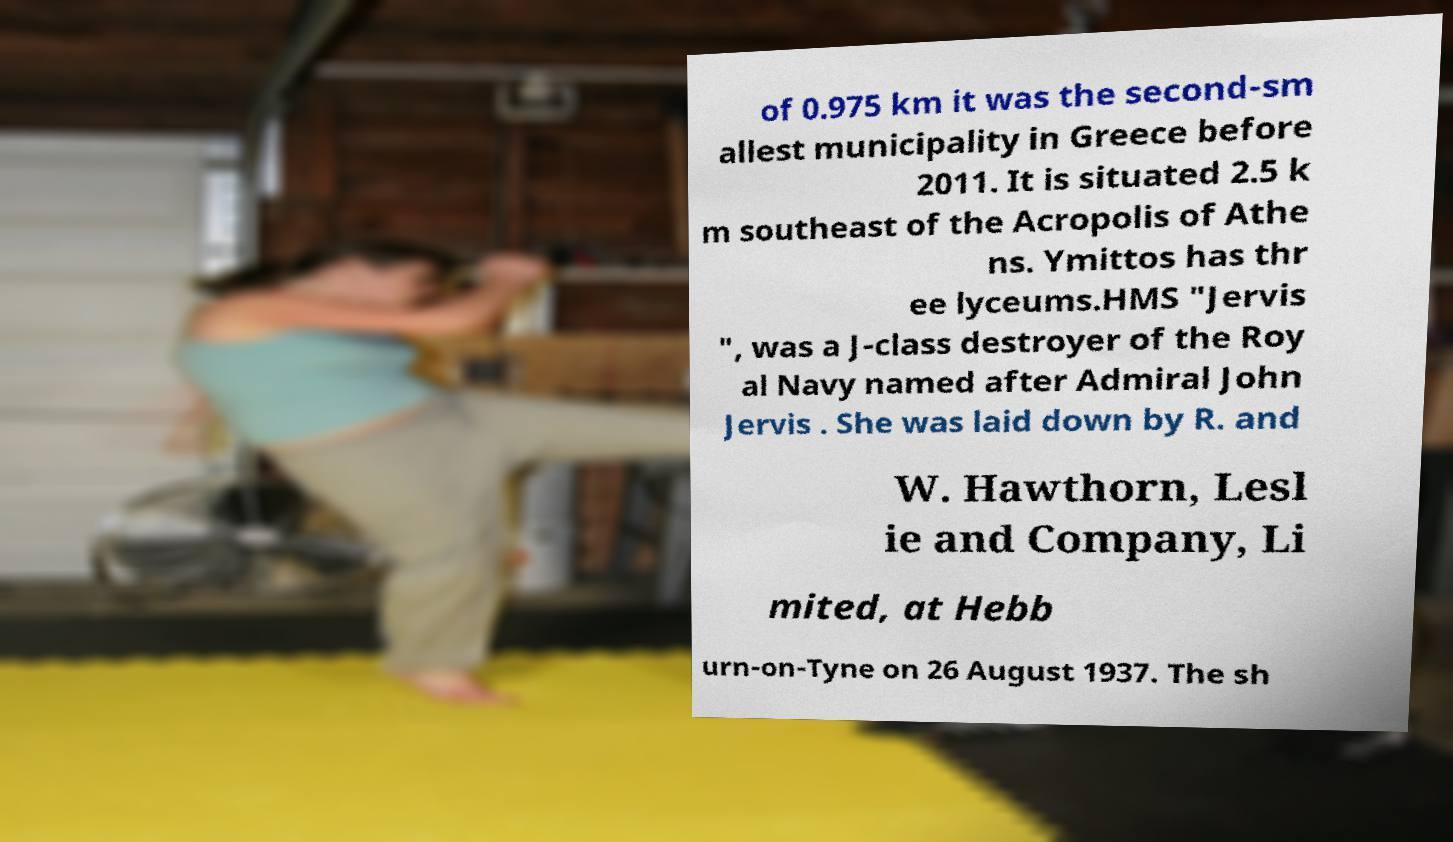Could you assist in decoding the text presented in this image and type it out clearly? of 0.975 km it was the second-sm allest municipality in Greece before 2011. It is situated 2.5 k m southeast of the Acropolis of Athe ns. Ymittos has thr ee lyceums.HMS "Jervis ", was a J-class destroyer of the Roy al Navy named after Admiral John Jervis . She was laid down by R. and W. Hawthorn, Lesl ie and Company, Li mited, at Hebb urn-on-Tyne on 26 August 1937. The sh 